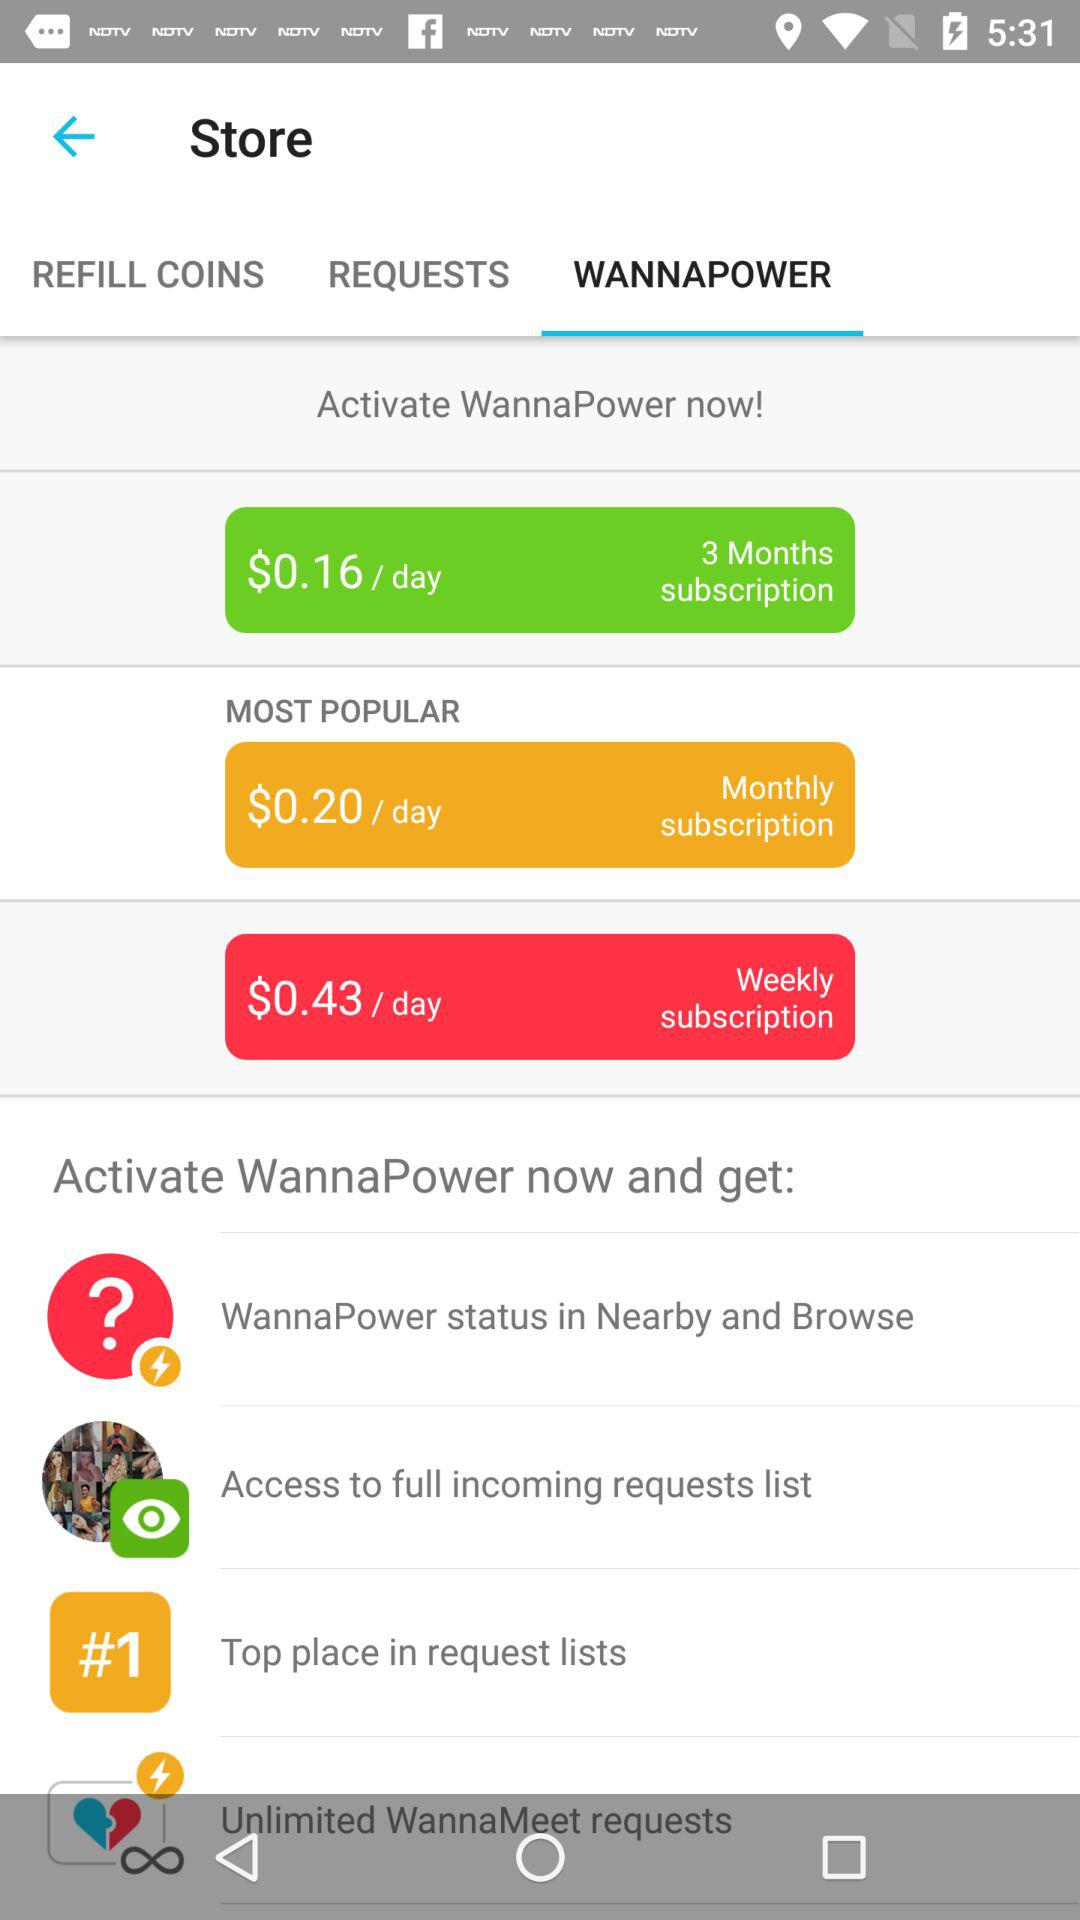What is the per day cost of a monthly subscription? The per day cost of a monthly subscription is $0.20. 